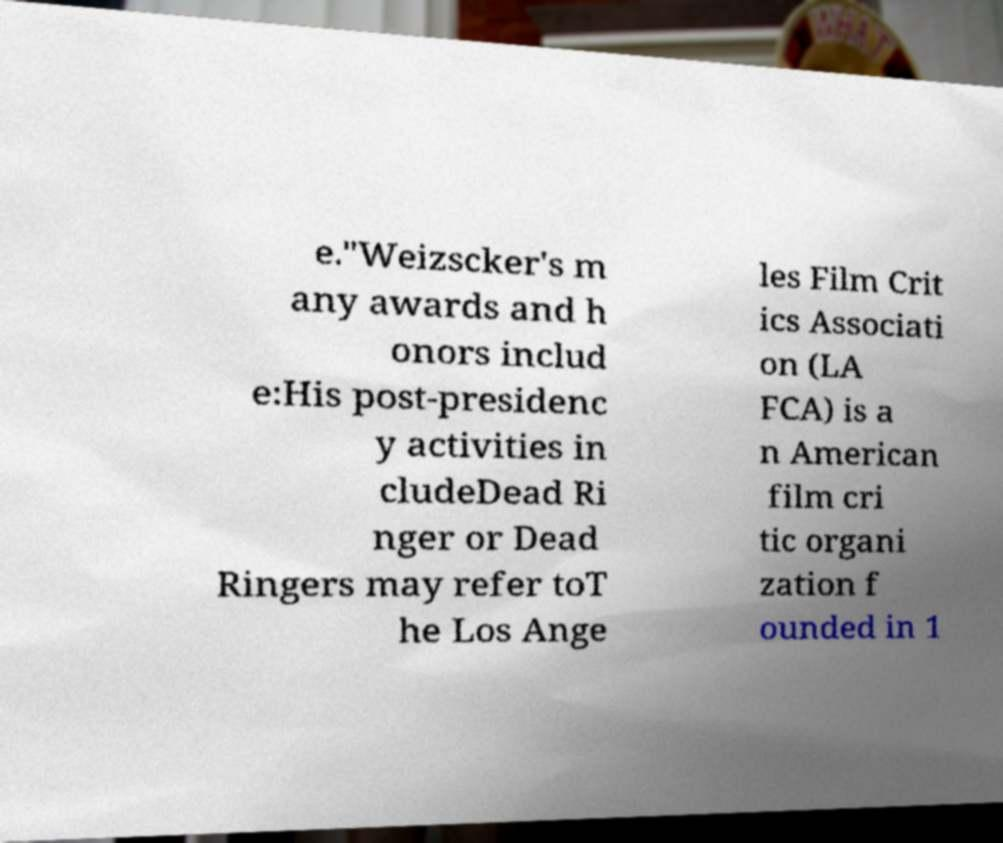Could you assist in decoding the text presented in this image and type it out clearly? e."Weizscker's m any awards and h onors includ e:His post-presidenc y activities in cludeDead Ri nger or Dead Ringers may refer toT he Los Ange les Film Crit ics Associati on (LA FCA) is a n American film cri tic organi zation f ounded in 1 